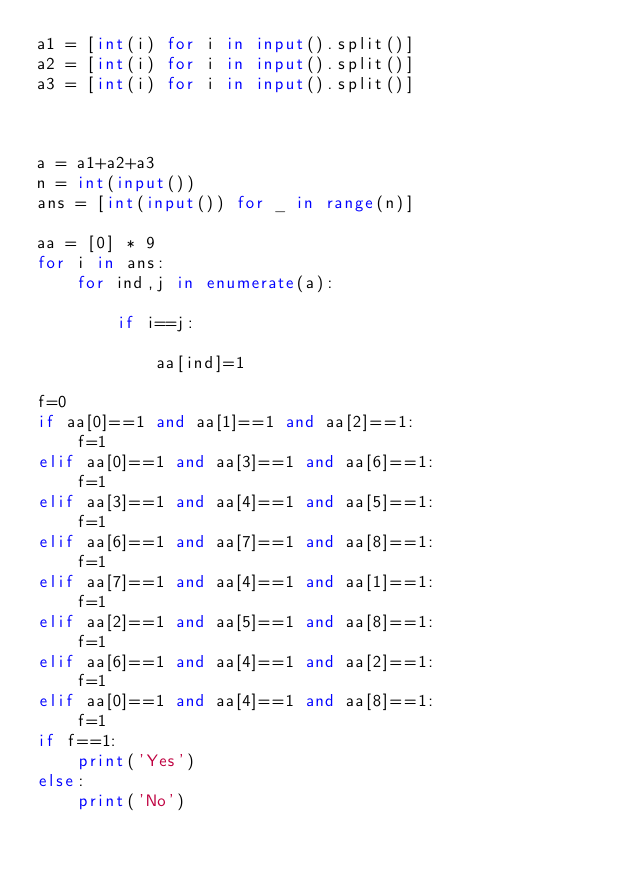<code> <loc_0><loc_0><loc_500><loc_500><_Python_>a1 = [int(i) for i in input().split()]
a2 = [int(i) for i in input().split()]
a3 = [int(i) for i in input().split()]



a = a1+a2+a3
n = int(input())
ans = [int(input()) for _ in range(n)]

aa = [0] * 9
for i in ans:
    for ind,j in enumerate(a):

        if i==j:

            aa[ind]=1

f=0
if aa[0]==1 and	aa[1]==1 and aa[2]==1:
    f=1
elif aa[0]==1 and aa[3]==1 and aa[6]==1:
    f=1
elif aa[3]==1 and aa[4]==1 and aa[5]==1:
    f=1
elif aa[6]==1 and aa[7]==1 and aa[8]==1:
    f=1
elif aa[7]==1 and aa[4]==1 and aa[1]==1:
    f=1
elif aa[2]==1 and aa[5]==1 and aa[8]==1:
    f=1
elif aa[6]==1 and aa[4]==1 and aa[2]==1:
    f=1
elif aa[0]==1 and aa[4]==1 and aa[8]==1:
    f=1
if f==1:
    print('Yes')
else:
    print('No')

</code> 